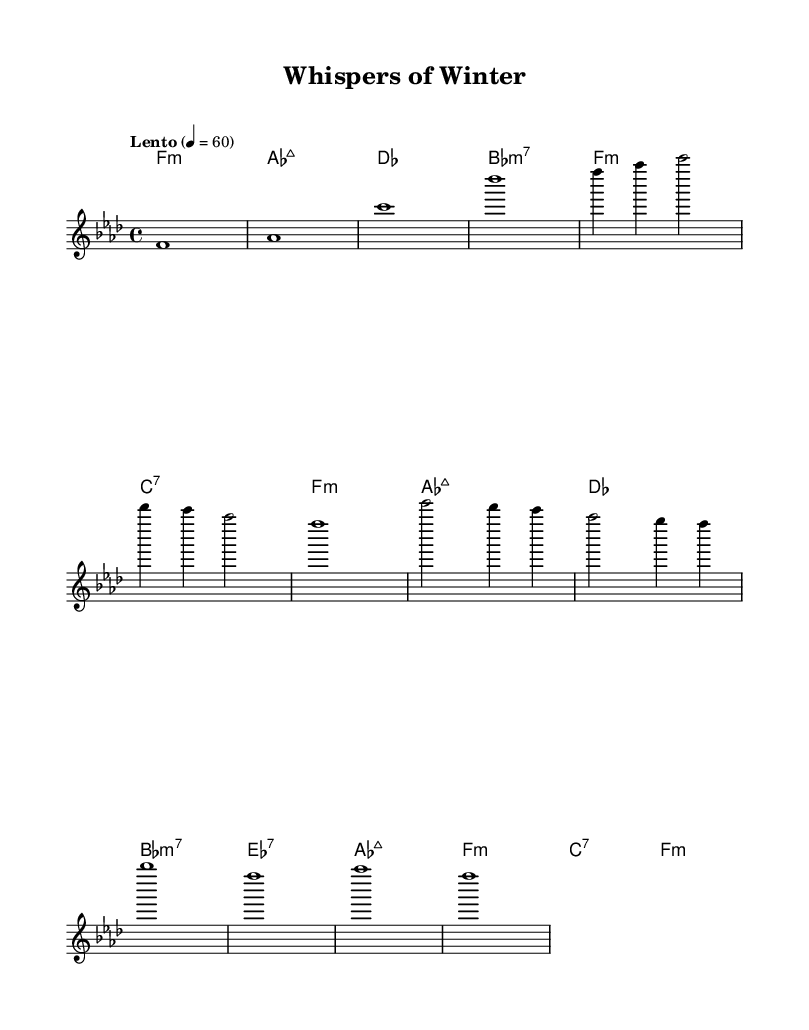What is the key signature of this music? The key signature is indicated by the presence of four flats, which corresponds to F minor. The flats are shown at the beginning of the staff.
Answer: F minor What is the time signature of this piece? The time signature is found at the beginning of the music, where it shows the fraction 4 over 4, indicating a common time.
Answer: 4/4 What is the tempo marking? The tempo marking is located at the start and states "Lento," which indicates a slow pace, along with a metronome marking of quarter note equals 60.
Answer: Lento How many measures are in Theme A? Theme A consists of two measures, which can be identified as the section that follows the introduction and is marked separately by the notation on the sheet music.
Answer: 2 What is the last note of the melody? The last note of the melody is indicated at the end of the score, which shows an F note. This is also supported by the final measure in the melody part.
Answer: F Which chord is played in measure three? Measure three shows the chord that corresponds to A-flat major 7, as indicated in the chord names below the staff.
Answer: A-flat major 7 What mood does the piece aim to evoke, based on its characteristics? The overall mood can be inferred from elements like the slow tempo, minor key, and long, sustained notes altogether suggest an introspective and serene atmosphere, typical for snowy landscapes.
Answer: Serene 